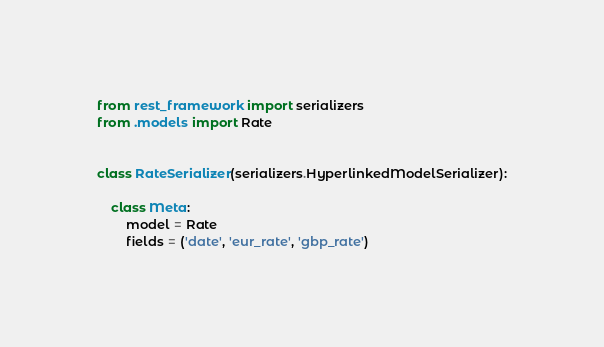Convert code to text. <code><loc_0><loc_0><loc_500><loc_500><_Python_>from rest_framework import serializers
from .models import Rate


class RateSerializer(serializers.HyperlinkedModelSerializer):

    class Meta:
        model = Rate
        fields = ('date', 'eur_rate', 'gbp_rate')
</code> 